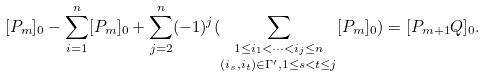<formula> <loc_0><loc_0><loc_500><loc_500>[ P _ { m } ] _ { 0 } - \underset { i = 1 } { \overset { n } { \sum } } [ P _ { m } ] _ { 0 } + \underset { j = 2 } { \overset { n } { \sum } } ( - 1 ) ^ { j } ( \underset { ( i _ { s } , i _ { t } ) \in \Gamma ^ { \prime } , 1 \leq s < t \leq j } { \underset { 1 \leq i _ { 1 } < \dots < i _ { j } \leq n } { \sum } } [ P _ { m } ] _ { 0 } ) = [ P _ { m + 1 } Q ] _ { 0 } .</formula> 